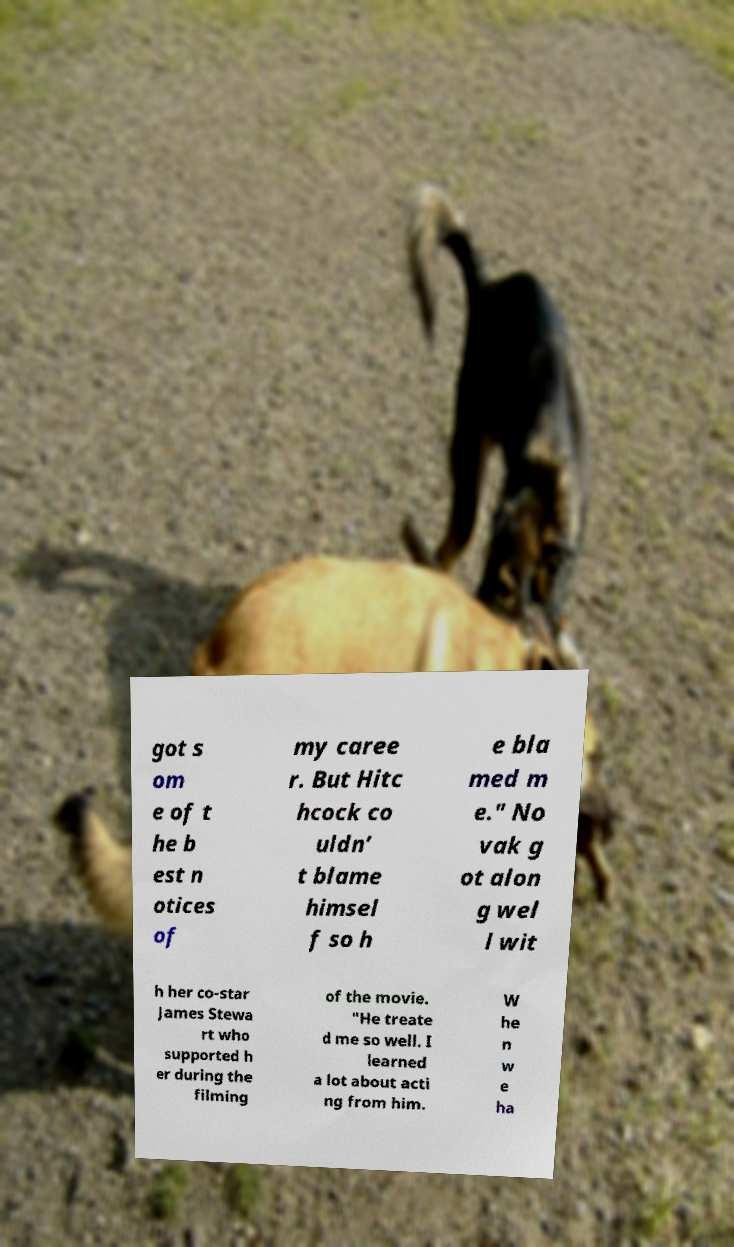For documentation purposes, I need the text within this image transcribed. Could you provide that? got s om e of t he b est n otices of my caree r. But Hitc hcock co uldn’ t blame himsel f so h e bla med m e." No vak g ot alon g wel l wit h her co-star James Stewa rt who supported h er during the filming of the movie. "He treate d me so well. I learned a lot about acti ng from him. W he n w e ha 